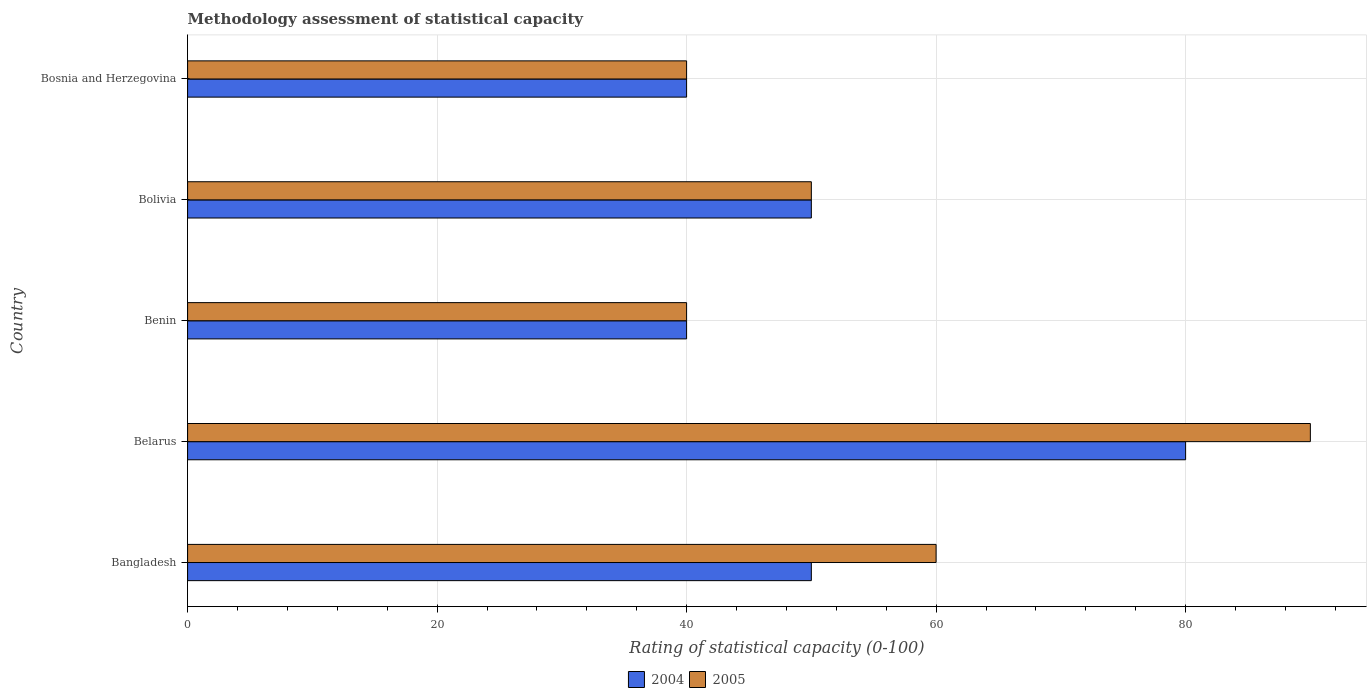How many different coloured bars are there?
Ensure brevity in your answer.  2. How many groups of bars are there?
Give a very brief answer. 5. How many bars are there on the 1st tick from the bottom?
Ensure brevity in your answer.  2. What is the label of the 3rd group of bars from the top?
Ensure brevity in your answer.  Benin. In how many cases, is the number of bars for a given country not equal to the number of legend labels?
Your answer should be very brief. 0. Across all countries, what is the minimum rating of statistical capacity in 2004?
Give a very brief answer. 40. In which country was the rating of statistical capacity in 2005 maximum?
Your answer should be compact. Belarus. In which country was the rating of statistical capacity in 2004 minimum?
Keep it short and to the point. Benin. What is the total rating of statistical capacity in 2004 in the graph?
Your response must be concise. 260. What is the difference between the rating of statistical capacity in 2005 in Belarus and that in Bolivia?
Your response must be concise. 40. What is the difference between the rating of statistical capacity in 2004 in Bangladesh and the rating of statistical capacity in 2005 in Bosnia and Herzegovina?
Give a very brief answer. 10. What is the difference between the rating of statistical capacity in 2005 and rating of statistical capacity in 2004 in Bangladesh?
Offer a very short reply. 10. What is the ratio of the rating of statistical capacity in 2005 in Bangladesh to that in Benin?
Your answer should be very brief. 1.5. Is the rating of statistical capacity in 2004 in Bolivia less than that in Bosnia and Herzegovina?
Your answer should be very brief. No. Is the difference between the rating of statistical capacity in 2005 in Benin and Bosnia and Herzegovina greater than the difference between the rating of statistical capacity in 2004 in Benin and Bosnia and Herzegovina?
Your answer should be very brief. No. What is the difference between the highest and the lowest rating of statistical capacity in 2005?
Provide a succinct answer. 50. What does the 2nd bar from the bottom in Bolivia represents?
Offer a very short reply. 2005. How many bars are there?
Your response must be concise. 10. Are all the bars in the graph horizontal?
Make the answer very short. Yes. What is the difference between two consecutive major ticks on the X-axis?
Keep it short and to the point. 20. Does the graph contain any zero values?
Make the answer very short. No. Where does the legend appear in the graph?
Provide a succinct answer. Bottom center. How are the legend labels stacked?
Your answer should be compact. Horizontal. What is the title of the graph?
Keep it short and to the point. Methodology assessment of statistical capacity. What is the label or title of the X-axis?
Give a very brief answer. Rating of statistical capacity (0-100). What is the Rating of statistical capacity (0-100) of 2004 in Bangladesh?
Your answer should be very brief. 50. What is the Rating of statistical capacity (0-100) in 2005 in Bangladesh?
Provide a succinct answer. 60. What is the Rating of statistical capacity (0-100) in 2004 in Belarus?
Keep it short and to the point. 80. What is the Rating of statistical capacity (0-100) of 2005 in Bolivia?
Your answer should be very brief. 50. What is the Rating of statistical capacity (0-100) in 2005 in Bosnia and Herzegovina?
Give a very brief answer. 40. Across all countries, what is the minimum Rating of statistical capacity (0-100) in 2004?
Make the answer very short. 40. What is the total Rating of statistical capacity (0-100) in 2004 in the graph?
Keep it short and to the point. 260. What is the total Rating of statistical capacity (0-100) of 2005 in the graph?
Offer a very short reply. 280. What is the difference between the Rating of statistical capacity (0-100) in 2004 in Bangladesh and that in Belarus?
Keep it short and to the point. -30. What is the difference between the Rating of statistical capacity (0-100) of 2004 in Bangladesh and that in Benin?
Provide a succinct answer. 10. What is the difference between the Rating of statistical capacity (0-100) of 2005 in Bangladesh and that in Benin?
Make the answer very short. 20. What is the difference between the Rating of statistical capacity (0-100) of 2005 in Bangladesh and that in Bolivia?
Offer a terse response. 10. What is the difference between the Rating of statistical capacity (0-100) in 2004 in Bangladesh and that in Bosnia and Herzegovina?
Offer a very short reply. 10. What is the difference between the Rating of statistical capacity (0-100) in 2005 in Bangladesh and that in Bosnia and Herzegovina?
Offer a very short reply. 20. What is the difference between the Rating of statistical capacity (0-100) in 2004 in Belarus and that in Benin?
Your response must be concise. 40. What is the difference between the Rating of statistical capacity (0-100) in 2005 in Belarus and that in Benin?
Give a very brief answer. 50. What is the difference between the Rating of statistical capacity (0-100) in 2004 in Belarus and that in Bosnia and Herzegovina?
Give a very brief answer. 40. What is the difference between the Rating of statistical capacity (0-100) in 2005 in Belarus and that in Bosnia and Herzegovina?
Your answer should be very brief. 50. What is the difference between the Rating of statistical capacity (0-100) of 2005 in Benin and that in Bolivia?
Make the answer very short. -10. What is the difference between the Rating of statistical capacity (0-100) of 2004 in Benin and that in Bosnia and Herzegovina?
Keep it short and to the point. 0. What is the difference between the Rating of statistical capacity (0-100) in 2004 in Bolivia and that in Bosnia and Herzegovina?
Make the answer very short. 10. What is the difference between the Rating of statistical capacity (0-100) of 2004 in Bangladesh and the Rating of statistical capacity (0-100) of 2005 in Belarus?
Make the answer very short. -40. What is the difference between the Rating of statistical capacity (0-100) in 2004 in Bangladesh and the Rating of statistical capacity (0-100) in 2005 in Benin?
Offer a very short reply. 10. What is the difference between the Rating of statistical capacity (0-100) in 2004 in Bangladesh and the Rating of statistical capacity (0-100) in 2005 in Bolivia?
Your answer should be compact. 0. What is the difference between the Rating of statistical capacity (0-100) in 2004 in Belarus and the Rating of statistical capacity (0-100) in 2005 in Benin?
Ensure brevity in your answer.  40. What is the difference between the Rating of statistical capacity (0-100) in 2004 in Belarus and the Rating of statistical capacity (0-100) in 2005 in Bolivia?
Provide a short and direct response. 30. What is the difference between the Rating of statistical capacity (0-100) of 2004 in Belarus and the Rating of statistical capacity (0-100) of 2005 in Bosnia and Herzegovina?
Make the answer very short. 40. What is the difference between the Rating of statistical capacity (0-100) in 2004 in Benin and the Rating of statistical capacity (0-100) in 2005 in Bosnia and Herzegovina?
Your response must be concise. 0. What is the average Rating of statistical capacity (0-100) in 2005 per country?
Give a very brief answer. 56. What is the difference between the Rating of statistical capacity (0-100) in 2004 and Rating of statistical capacity (0-100) in 2005 in Bosnia and Herzegovina?
Your response must be concise. 0. What is the ratio of the Rating of statistical capacity (0-100) in 2005 in Bangladesh to that in Benin?
Offer a terse response. 1.5. What is the ratio of the Rating of statistical capacity (0-100) of 2004 in Bangladesh to that in Bolivia?
Make the answer very short. 1. What is the ratio of the Rating of statistical capacity (0-100) in 2005 in Bangladesh to that in Bosnia and Herzegovina?
Offer a very short reply. 1.5. What is the ratio of the Rating of statistical capacity (0-100) in 2005 in Belarus to that in Benin?
Make the answer very short. 2.25. What is the ratio of the Rating of statistical capacity (0-100) of 2005 in Belarus to that in Bosnia and Herzegovina?
Give a very brief answer. 2.25. What is the ratio of the Rating of statistical capacity (0-100) of 2004 in Benin to that in Bosnia and Herzegovina?
Give a very brief answer. 1. What is the ratio of the Rating of statistical capacity (0-100) of 2005 in Benin to that in Bosnia and Herzegovina?
Ensure brevity in your answer.  1. What is the difference between the highest and the second highest Rating of statistical capacity (0-100) of 2004?
Your response must be concise. 30. What is the difference between the highest and the second highest Rating of statistical capacity (0-100) in 2005?
Your response must be concise. 30. What is the difference between the highest and the lowest Rating of statistical capacity (0-100) of 2004?
Ensure brevity in your answer.  40. 